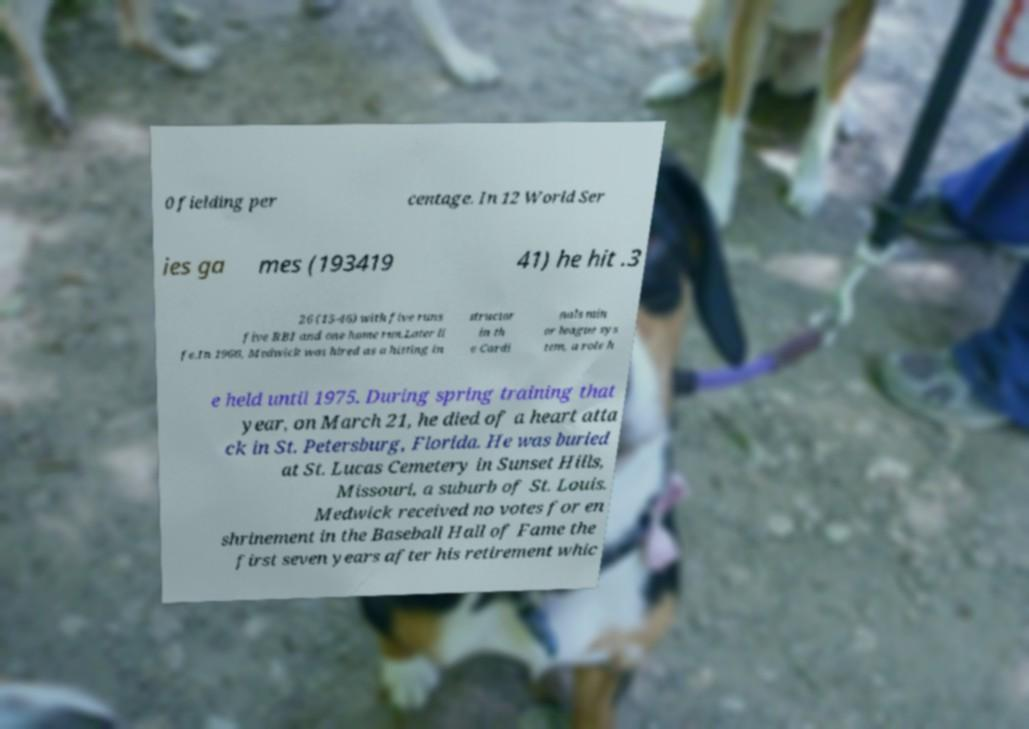What messages or text are displayed in this image? I need them in a readable, typed format. 0 fielding per centage. In 12 World Ser ies ga mes (193419 41) he hit .3 26 (15-46) with five runs five RBI and one home run.Later li fe.In 1966, Medwick was hired as a hitting in structor in th e Cardi nals min or league sys tem, a role h e held until 1975. During spring training that year, on March 21, he died of a heart atta ck in St. Petersburg, Florida. He was buried at St. Lucas Cemetery in Sunset Hills, Missouri, a suburb of St. Louis. Medwick received no votes for en shrinement in the Baseball Hall of Fame the first seven years after his retirement whic 